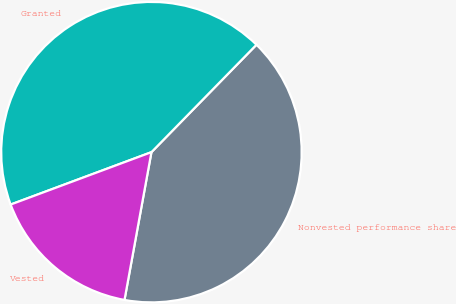Convert chart. <chart><loc_0><loc_0><loc_500><loc_500><pie_chart><fcel>Nonvested performance share<fcel>Granted<fcel>Vested<nl><fcel>40.55%<fcel>42.99%<fcel>16.46%<nl></chart> 